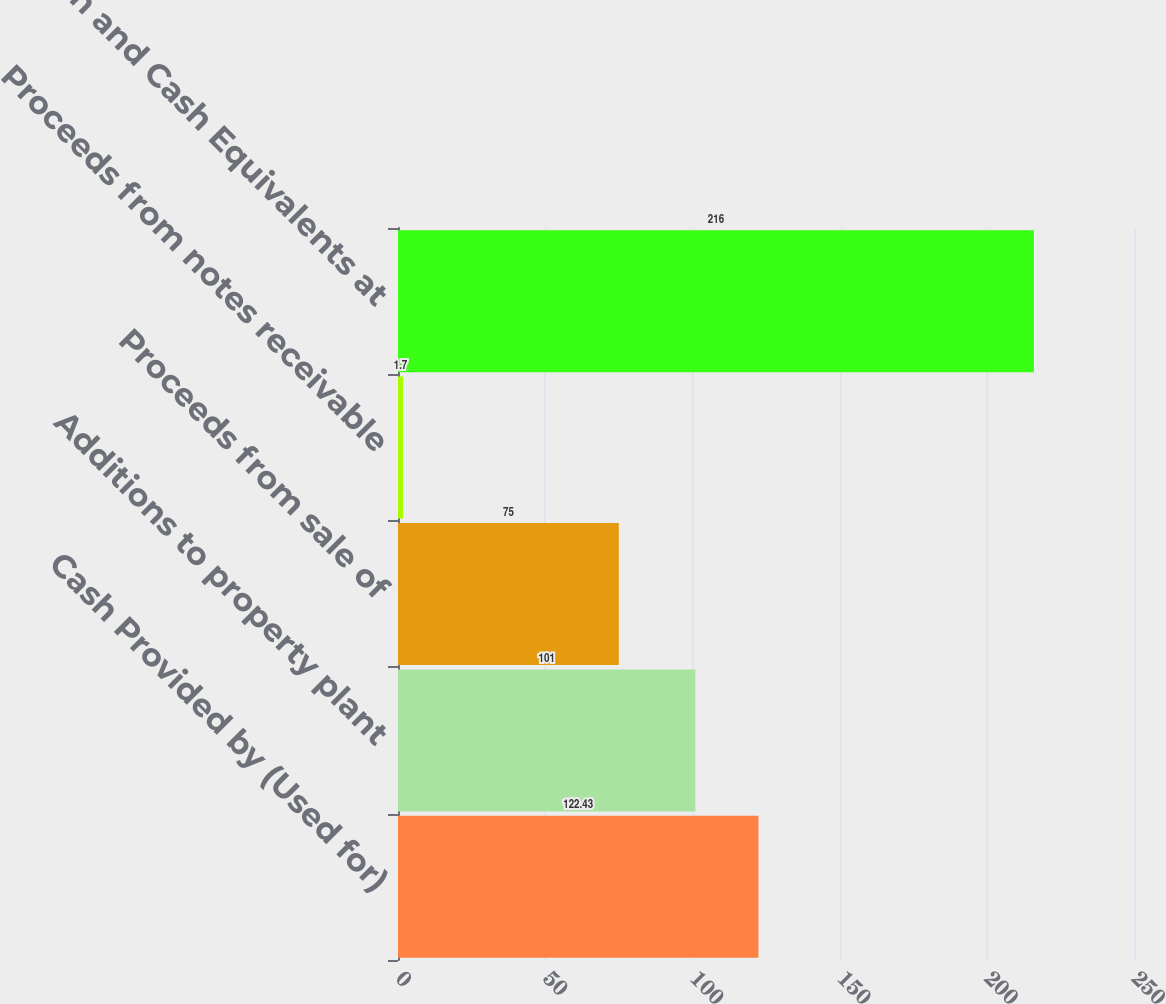Convert chart to OTSL. <chart><loc_0><loc_0><loc_500><loc_500><bar_chart><fcel>Cash Provided by (Used for)<fcel>Additions to property plant<fcel>Proceeds from sale of<fcel>Proceeds from notes receivable<fcel>Cash and Cash Equivalents at<nl><fcel>122.43<fcel>101<fcel>75<fcel>1.7<fcel>216<nl></chart> 